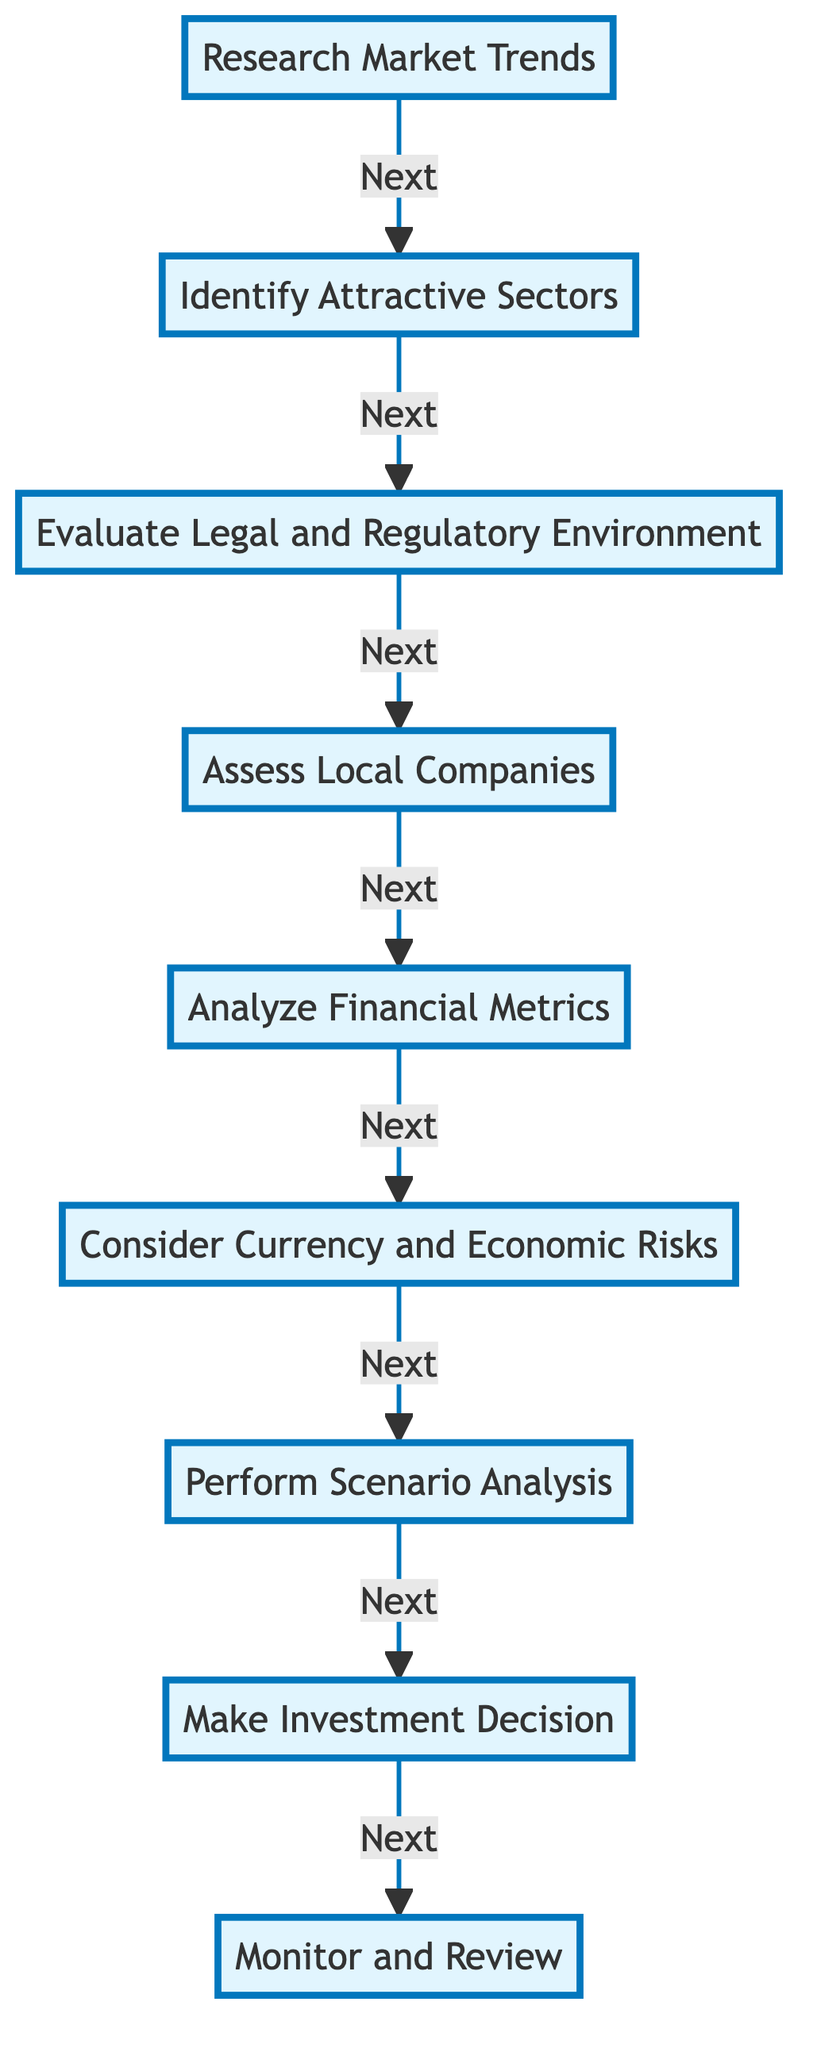What’s the first step in evaluating investment opportunities? The diagram indicates that "Research Market Trends" is the first step, as it is the starting node in the flow chart.
Answer: Research Market Trends How many steps are there in total? By counting each individual step from "Research Market Trends" to "Monitor and Review," there are a total of eight distinct steps in the flow chart.
Answer: Eight What is the last step of the evaluation process? The diagram shows that the last step in the process is "Monitor and Review," which is the final node in the flow chart and has no following step.
Answer: Monitor and Review What step comes after analyzing financial metrics? According to the flow chart, the step that follows "Analyze Financial Metrics" is "Consider Currency and Economic Risks," as indicated by the directed arrow leading from one to the other.
Answer: Consider Currency and Economic Risks Which step focuses on potential currency risks? "Consider Currency and Economic Risks" is the step specifically dedicated to analyzing currency risks, as noted directly in the step’s description.
Answer: Consider Currency and Economic Risks What is the relationship between "Assess Local Companies" and "Evaluate Legal and Regulatory Environment"? The flow shows a direct connection from "Evaluate Legal and Regulatory Environment" leading to "Assess Local Companies," indicating that the latter follows the former in the sequence of steps.
Answer: Assess Local Companies follows Evaluate Legal and Regulatory Environment Which entity is associated with "Make Investment Decision"? The step "Make Investment Decision" does not list any associated real-world entities in the diagram, which means it is independent of external references.
Answer: None Which step involves financial health and management team review? The "Assess Local Companies" step involves reviewing the financial health and management team of companies, as per its description in the diagram.
Answer: Assess Local Companies What is the purpose of "Perform Scenario Analysis"? The purpose of "Perform Scenario Analysis" is to simulate different economic scenarios to understand potential outcomes and risks, as suggested by the description linked to that step.
Answer: Understand potential outcomes and risks 